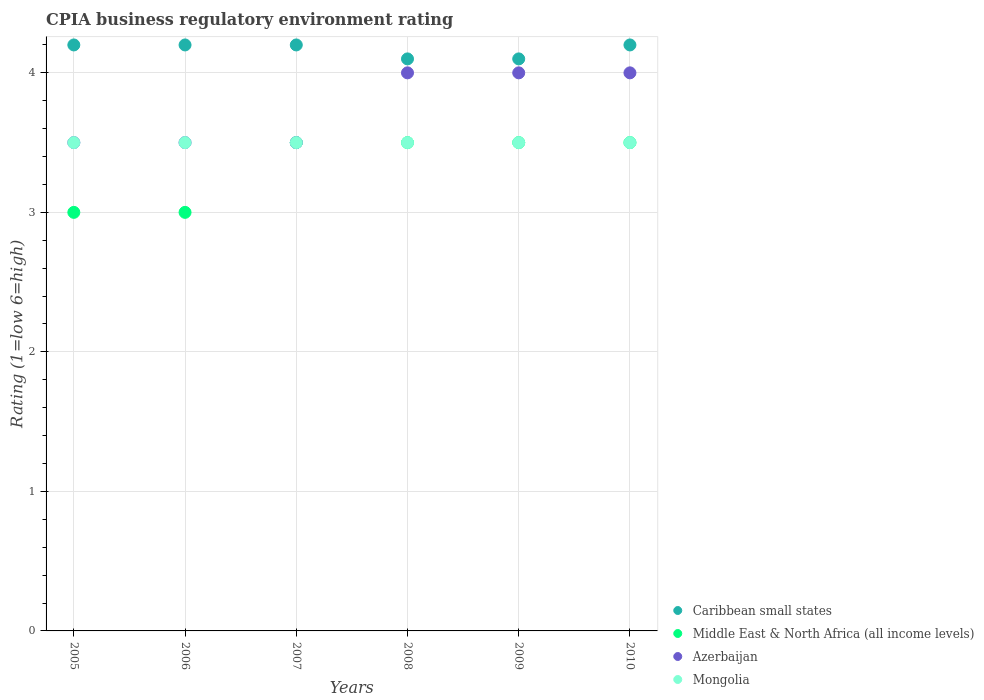Is the number of dotlines equal to the number of legend labels?
Offer a terse response. Yes. Across all years, what is the maximum CPIA rating in Caribbean small states?
Provide a short and direct response. 4.2. Across all years, what is the minimum CPIA rating in Mongolia?
Provide a short and direct response. 3.5. In which year was the CPIA rating in Caribbean small states maximum?
Give a very brief answer. 2005. In which year was the CPIA rating in Azerbaijan minimum?
Provide a succinct answer. 2005. What is the difference between the CPIA rating in Caribbean small states in 2009 and the CPIA rating in Middle East & North Africa (all income levels) in 2010?
Keep it short and to the point. 0.6. What is the average CPIA rating in Middle East & North Africa (all income levels) per year?
Make the answer very short. 3.33. In the year 2010, what is the difference between the CPIA rating in Caribbean small states and CPIA rating in Azerbaijan?
Make the answer very short. 0.2. In how many years, is the CPIA rating in Caribbean small states greater than 3.4?
Offer a very short reply. 6. Is the CPIA rating in Middle East & North Africa (all income levels) in 2005 less than that in 2010?
Your response must be concise. Yes. Is the difference between the CPIA rating in Caribbean small states in 2007 and 2010 greater than the difference between the CPIA rating in Azerbaijan in 2007 and 2010?
Provide a short and direct response. Yes. What is the difference between the highest and the lowest CPIA rating in Caribbean small states?
Offer a terse response. 0.1. In how many years, is the CPIA rating in Caribbean small states greater than the average CPIA rating in Caribbean small states taken over all years?
Provide a succinct answer. 4. Is the sum of the CPIA rating in Caribbean small states in 2005 and 2009 greater than the maximum CPIA rating in Middle East & North Africa (all income levels) across all years?
Offer a very short reply. Yes. Does the CPIA rating in Azerbaijan monotonically increase over the years?
Keep it short and to the point. No. How many years are there in the graph?
Provide a short and direct response. 6. Does the graph contain any zero values?
Provide a succinct answer. No. What is the title of the graph?
Offer a very short reply. CPIA business regulatory environment rating. Does "Botswana" appear as one of the legend labels in the graph?
Ensure brevity in your answer.  No. What is the label or title of the X-axis?
Offer a terse response. Years. What is the Rating (1=low 6=high) of Middle East & North Africa (all income levels) in 2005?
Your response must be concise. 3. What is the Rating (1=low 6=high) in Mongolia in 2005?
Keep it short and to the point. 3.5. What is the Rating (1=low 6=high) of Azerbaijan in 2006?
Keep it short and to the point. 3.5. What is the Rating (1=low 6=high) of Caribbean small states in 2007?
Offer a terse response. 4.2. What is the Rating (1=low 6=high) in Middle East & North Africa (all income levels) in 2007?
Your answer should be compact. 3.5. What is the Rating (1=low 6=high) in Azerbaijan in 2007?
Offer a terse response. 3.5. What is the Rating (1=low 6=high) in Mongolia in 2007?
Give a very brief answer. 3.5. What is the Rating (1=low 6=high) in Caribbean small states in 2008?
Provide a succinct answer. 4.1. What is the Rating (1=low 6=high) of Middle East & North Africa (all income levels) in 2008?
Make the answer very short. 3.5. What is the Rating (1=low 6=high) in Azerbaijan in 2008?
Offer a very short reply. 4. What is the Rating (1=low 6=high) of Mongolia in 2008?
Provide a short and direct response. 3.5. What is the Rating (1=low 6=high) in Caribbean small states in 2009?
Ensure brevity in your answer.  4.1. What is the Rating (1=low 6=high) of Middle East & North Africa (all income levels) in 2009?
Your answer should be compact. 3.5. What is the Rating (1=low 6=high) of Azerbaijan in 2009?
Keep it short and to the point. 4. What is the Rating (1=low 6=high) of Middle East & North Africa (all income levels) in 2010?
Offer a terse response. 3.5. What is the Rating (1=low 6=high) in Azerbaijan in 2010?
Keep it short and to the point. 4. Across all years, what is the maximum Rating (1=low 6=high) in Mongolia?
Make the answer very short. 3.5. Across all years, what is the minimum Rating (1=low 6=high) in Caribbean small states?
Your answer should be very brief. 4.1. Across all years, what is the minimum Rating (1=low 6=high) in Azerbaijan?
Keep it short and to the point. 3.5. Across all years, what is the minimum Rating (1=low 6=high) of Mongolia?
Provide a succinct answer. 3.5. What is the total Rating (1=low 6=high) in Caribbean small states in the graph?
Keep it short and to the point. 25. What is the total Rating (1=low 6=high) of Middle East & North Africa (all income levels) in the graph?
Provide a succinct answer. 20. What is the total Rating (1=low 6=high) of Azerbaijan in the graph?
Make the answer very short. 22.5. What is the total Rating (1=low 6=high) in Mongolia in the graph?
Provide a short and direct response. 21. What is the difference between the Rating (1=low 6=high) of Azerbaijan in 2005 and that in 2006?
Your response must be concise. 0. What is the difference between the Rating (1=low 6=high) of Caribbean small states in 2005 and that in 2007?
Provide a short and direct response. 0. What is the difference between the Rating (1=low 6=high) of Mongolia in 2005 and that in 2007?
Give a very brief answer. 0. What is the difference between the Rating (1=low 6=high) of Middle East & North Africa (all income levels) in 2005 and that in 2008?
Keep it short and to the point. -0.5. What is the difference between the Rating (1=low 6=high) in Azerbaijan in 2005 and that in 2008?
Provide a short and direct response. -0.5. What is the difference between the Rating (1=low 6=high) in Mongolia in 2005 and that in 2008?
Give a very brief answer. 0. What is the difference between the Rating (1=low 6=high) of Caribbean small states in 2005 and that in 2009?
Make the answer very short. 0.1. What is the difference between the Rating (1=low 6=high) in Middle East & North Africa (all income levels) in 2005 and that in 2009?
Your answer should be compact. -0.5. What is the difference between the Rating (1=low 6=high) of Azerbaijan in 2005 and that in 2009?
Make the answer very short. -0.5. What is the difference between the Rating (1=low 6=high) of Mongolia in 2005 and that in 2009?
Offer a very short reply. 0. What is the difference between the Rating (1=low 6=high) of Middle East & North Africa (all income levels) in 2005 and that in 2010?
Your response must be concise. -0.5. What is the difference between the Rating (1=low 6=high) in Mongolia in 2005 and that in 2010?
Provide a short and direct response. 0. What is the difference between the Rating (1=low 6=high) in Azerbaijan in 2006 and that in 2007?
Keep it short and to the point. 0. What is the difference between the Rating (1=low 6=high) in Mongolia in 2006 and that in 2007?
Ensure brevity in your answer.  0. What is the difference between the Rating (1=low 6=high) in Middle East & North Africa (all income levels) in 2006 and that in 2008?
Your response must be concise. -0.5. What is the difference between the Rating (1=low 6=high) of Mongolia in 2006 and that in 2008?
Offer a very short reply. 0. What is the difference between the Rating (1=low 6=high) in Azerbaijan in 2006 and that in 2009?
Offer a terse response. -0.5. What is the difference between the Rating (1=low 6=high) of Caribbean small states in 2006 and that in 2010?
Keep it short and to the point. 0. What is the difference between the Rating (1=low 6=high) in Middle East & North Africa (all income levels) in 2006 and that in 2010?
Give a very brief answer. -0.5. What is the difference between the Rating (1=low 6=high) in Caribbean small states in 2007 and that in 2008?
Your answer should be compact. 0.1. What is the difference between the Rating (1=low 6=high) of Azerbaijan in 2007 and that in 2008?
Offer a very short reply. -0.5. What is the difference between the Rating (1=low 6=high) of Azerbaijan in 2007 and that in 2009?
Ensure brevity in your answer.  -0.5. What is the difference between the Rating (1=low 6=high) of Middle East & North Africa (all income levels) in 2007 and that in 2010?
Your answer should be compact. 0. What is the difference between the Rating (1=low 6=high) of Azerbaijan in 2008 and that in 2009?
Your answer should be compact. 0. What is the difference between the Rating (1=low 6=high) in Caribbean small states in 2008 and that in 2010?
Give a very brief answer. -0.1. What is the difference between the Rating (1=low 6=high) of Middle East & North Africa (all income levels) in 2008 and that in 2010?
Provide a succinct answer. 0. What is the difference between the Rating (1=low 6=high) of Caribbean small states in 2009 and that in 2010?
Keep it short and to the point. -0.1. What is the difference between the Rating (1=low 6=high) in Middle East & North Africa (all income levels) in 2009 and that in 2010?
Provide a short and direct response. 0. What is the difference between the Rating (1=low 6=high) of Mongolia in 2009 and that in 2010?
Provide a short and direct response. 0. What is the difference between the Rating (1=low 6=high) of Caribbean small states in 2005 and the Rating (1=low 6=high) of Azerbaijan in 2006?
Give a very brief answer. 0.7. What is the difference between the Rating (1=low 6=high) of Caribbean small states in 2005 and the Rating (1=low 6=high) of Mongolia in 2006?
Make the answer very short. 0.7. What is the difference between the Rating (1=low 6=high) in Middle East & North Africa (all income levels) in 2005 and the Rating (1=low 6=high) in Mongolia in 2006?
Provide a short and direct response. -0.5. What is the difference between the Rating (1=low 6=high) in Caribbean small states in 2005 and the Rating (1=low 6=high) in Mongolia in 2007?
Ensure brevity in your answer.  0.7. What is the difference between the Rating (1=low 6=high) in Middle East & North Africa (all income levels) in 2005 and the Rating (1=low 6=high) in Azerbaijan in 2007?
Your answer should be very brief. -0.5. What is the difference between the Rating (1=low 6=high) in Middle East & North Africa (all income levels) in 2005 and the Rating (1=low 6=high) in Mongolia in 2007?
Offer a terse response. -0.5. What is the difference between the Rating (1=low 6=high) in Caribbean small states in 2005 and the Rating (1=low 6=high) in Middle East & North Africa (all income levels) in 2008?
Ensure brevity in your answer.  0.7. What is the difference between the Rating (1=low 6=high) of Caribbean small states in 2005 and the Rating (1=low 6=high) of Middle East & North Africa (all income levels) in 2009?
Provide a short and direct response. 0.7. What is the difference between the Rating (1=low 6=high) in Caribbean small states in 2005 and the Rating (1=low 6=high) in Azerbaijan in 2009?
Make the answer very short. 0.2. What is the difference between the Rating (1=low 6=high) of Middle East & North Africa (all income levels) in 2005 and the Rating (1=low 6=high) of Mongolia in 2009?
Ensure brevity in your answer.  -0.5. What is the difference between the Rating (1=low 6=high) in Azerbaijan in 2005 and the Rating (1=low 6=high) in Mongolia in 2009?
Your response must be concise. 0. What is the difference between the Rating (1=low 6=high) in Caribbean small states in 2005 and the Rating (1=low 6=high) in Middle East & North Africa (all income levels) in 2010?
Offer a terse response. 0.7. What is the difference between the Rating (1=low 6=high) in Caribbean small states in 2005 and the Rating (1=low 6=high) in Azerbaijan in 2010?
Provide a short and direct response. 0.2. What is the difference between the Rating (1=low 6=high) of Caribbean small states in 2005 and the Rating (1=low 6=high) of Mongolia in 2010?
Make the answer very short. 0.7. What is the difference between the Rating (1=low 6=high) of Middle East & North Africa (all income levels) in 2005 and the Rating (1=low 6=high) of Azerbaijan in 2010?
Provide a short and direct response. -1. What is the difference between the Rating (1=low 6=high) of Middle East & North Africa (all income levels) in 2005 and the Rating (1=low 6=high) of Mongolia in 2010?
Provide a short and direct response. -0.5. What is the difference between the Rating (1=low 6=high) in Azerbaijan in 2005 and the Rating (1=low 6=high) in Mongolia in 2010?
Provide a succinct answer. 0. What is the difference between the Rating (1=low 6=high) of Middle East & North Africa (all income levels) in 2006 and the Rating (1=low 6=high) of Mongolia in 2007?
Provide a succinct answer. -0.5. What is the difference between the Rating (1=low 6=high) of Caribbean small states in 2006 and the Rating (1=low 6=high) of Middle East & North Africa (all income levels) in 2008?
Give a very brief answer. 0.7. What is the difference between the Rating (1=low 6=high) in Caribbean small states in 2006 and the Rating (1=low 6=high) in Azerbaijan in 2008?
Ensure brevity in your answer.  0.2. What is the difference between the Rating (1=low 6=high) in Caribbean small states in 2006 and the Rating (1=low 6=high) in Mongolia in 2008?
Your response must be concise. 0.7. What is the difference between the Rating (1=low 6=high) of Middle East & North Africa (all income levels) in 2006 and the Rating (1=low 6=high) of Azerbaijan in 2008?
Your answer should be compact. -1. What is the difference between the Rating (1=low 6=high) of Middle East & North Africa (all income levels) in 2006 and the Rating (1=low 6=high) of Mongolia in 2008?
Keep it short and to the point. -0.5. What is the difference between the Rating (1=low 6=high) of Caribbean small states in 2006 and the Rating (1=low 6=high) of Azerbaijan in 2009?
Offer a terse response. 0.2. What is the difference between the Rating (1=low 6=high) in Middle East & North Africa (all income levels) in 2006 and the Rating (1=low 6=high) in Azerbaijan in 2009?
Offer a terse response. -1. What is the difference between the Rating (1=low 6=high) in Azerbaijan in 2006 and the Rating (1=low 6=high) in Mongolia in 2009?
Offer a terse response. 0. What is the difference between the Rating (1=low 6=high) of Caribbean small states in 2006 and the Rating (1=low 6=high) of Middle East & North Africa (all income levels) in 2010?
Keep it short and to the point. 0.7. What is the difference between the Rating (1=low 6=high) in Caribbean small states in 2006 and the Rating (1=low 6=high) in Azerbaijan in 2010?
Provide a succinct answer. 0.2. What is the difference between the Rating (1=low 6=high) in Caribbean small states in 2006 and the Rating (1=low 6=high) in Mongolia in 2010?
Keep it short and to the point. 0.7. What is the difference between the Rating (1=low 6=high) in Caribbean small states in 2007 and the Rating (1=low 6=high) in Middle East & North Africa (all income levels) in 2008?
Your answer should be compact. 0.7. What is the difference between the Rating (1=low 6=high) of Caribbean small states in 2007 and the Rating (1=low 6=high) of Azerbaijan in 2008?
Your response must be concise. 0.2. What is the difference between the Rating (1=low 6=high) of Caribbean small states in 2007 and the Rating (1=low 6=high) of Mongolia in 2008?
Ensure brevity in your answer.  0.7. What is the difference between the Rating (1=low 6=high) of Caribbean small states in 2007 and the Rating (1=low 6=high) of Middle East & North Africa (all income levels) in 2009?
Make the answer very short. 0.7. What is the difference between the Rating (1=low 6=high) of Caribbean small states in 2007 and the Rating (1=low 6=high) of Azerbaijan in 2009?
Provide a succinct answer. 0.2. What is the difference between the Rating (1=low 6=high) in Caribbean small states in 2007 and the Rating (1=low 6=high) in Mongolia in 2009?
Offer a very short reply. 0.7. What is the difference between the Rating (1=low 6=high) of Middle East & North Africa (all income levels) in 2007 and the Rating (1=low 6=high) of Mongolia in 2009?
Offer a very short reply. 0. What is the difference between the Rating (1=low 6=high) in Caribbean small states in 2007 and the Rating (1=low 6=high) in Mongolia in 2010?
Your response must be concise. 0.7. What is the difference between the Rating (1=low 6=high) in Middle East & North Africa (all income levels) in 2007 and the Rating (1=low 6=high) in Azerbaijan in 2010?
Offer a very short reply. -0.5. What is the difference between the Rating (1=low 6=high) of Azerbaijan in 2007 and the Rating (1=low 6=high) of Mongolia in 2010?
Offer a terse response. 0. What is the difference between the Rating (1=low 6=high) of Caribbean small states in 2008 and the Rating (1=low 6=high) of Azerbaijan in 2009?
Make the answer very short. 0.1. What is the difference between the Rating (1=low 6=high) in Azerbaijan in 2008 and the Rating (1=low 6=high) in Mongolia in 2009?
Give a very brief answer. 0.5. What is the difference between the Rating (1=low 6=high) of Caribbean small states in 2008 and the Rating (1=low 6=high) of Middle East & North Africa (all income levels) in 2010?
Ensure brevity in your answer.  0.6. What is the difference between the Rating (1=low 6=high) in Caribbean small states in 2008 and the Rating (1=low 6=high) in Azerbaijan in 2010?
Ensure brevity in your answer.  0.1. What is the difference between the Rating (1=low 6=high) in Caribbean small states in 2008 and the Rating (1=low 6=high) in Mongolia in 2010?
Ensure brevity in your answer.  0.6. What is the difference between the Rating (1=low 6=high) in Middle East & North Africa (all income levels) in 2008 and the Rating (1=low 6=high) in Mongolia in 2010?
Your answer should be compact. 0. What is the difference between the Rating (1=low 6=high) of Azerbaijan in 2008 and the Rating (1=low 6=high) of Mongolia in 2010?
Ensure brevity in your answer.  0.5. What is the difference between the Rating (1=low 6=high) in Caribbean small states in 2009 and the Rating (1=low 6=high) in Mongolia in 2010?
Provide a succinct answer. 0.6. What is the difference between the Rating (1=low 6=high) in Middle East & North Africa (all income levels) in 2009 and the Rating (1=low 6=high) in Azerbaijan in 2010?
Ensure brevity in your answer.  -0.5. What is the difference between the Rating (1=low 6=high) in Azerbaijan in 2009 and the Rating (1=low 6=high) in Mongolia in 2010?
Your answer should be compact. 0.5. What is the average Rating (1=low 6=high) in Caribbean small states per year?
Give a very brief answer. 4.17. What is the average Rating (1=low 6=high) in Azerbaijan per year?
Provide a succinct answer. 3.75. What is the average Rating (1=low 6=high) of Mongolia per year?
Make the answer very short. 3.5. In the year 2005, what is the difference between the Rating (1=low 6=high) of Caribbean small states and Rating (1=low 6=high) of Azerbaijan?
Make the answer very short. 0.7. In the year 2005, what is the difference between the Rating (1=low 6=high) of Caribbean small states and Rating (1=low 6=high) of Mongolia?
Ensure brevity in your answer.  0.7. In the year 2005, what is the difference between the Rating (1=low 6=high) in Middle East & North Africa (all income levels) and Rating (1=low 6=high) in Azerbaijan?
Give a very brief answer. -0.5. In the year 2006, what is the difference between the Rating (1=low 6=high) in Caribbean small states and Rating (1=low 6=high) in Middle East & North Africa (all income levels)?
Your answer should be very brief. 1.2. In the year 2006, what is the difference between the Rating (1=low 6=high) of Caribbean small states and Rating (1=low 6=high) of Azerbaijan?
Give a very brief answer. 0.7. In the year 2006, what is the difference between the Rating (1=low 6=high) in Middle East & North Africa (all income levels) and Rating (1=low 6=high) in Azerbaijan?
Give a very brief answer. -0.5. In the year 2006, what is the difference between the Rating (1=low 6=high) of Middle East & North Africa (all income levels) and Rating (1=low 6=high) of Mongolia?
Ensure brevity in your answer.  -0.5. In the year 2006, what is the difference between the Rating (1=low 6=high) in Azerbaijan and Rating (1=low 6=high) in Mongolia?
Make the answer very short. 0. In the year 2007, what is the difference between the Rating (1=low 6=high) in Caribbean small states and Rating (1=low 6=high) in Middle East & North Africa (all income levels)?
Ensure brevity in your answer.  0.7. In the year 2008, what is the difference between the Rating (1=low 6=high) in Caribbean small states and Rating (1=low 6=high) in Azerbaijan?
Your answer should be compact. 0.1. In the year 2008, what is the difference between the Rating (1=low 6=high) of Middle East & North Africa (all income levels) and Rating (1=low 6=high) of Azerbaijan?
Your answer should be compact. -0.5. In the year 2008, what is the difference between the Rating (1=low 6=high) in Middle East & North Africa (all income levels) and Rating (1=low 6=high) in Mongolia?
Keep it short and to the point. 0. In the year 2009, what is the difference between the Rating (1=low 6=high) of Caribbean small states and Rating (1=low 6=high) of Mongolia?
Provide a short and direct response. 0.6. In the year 2009, what is the difference between the Rating (1=low 6=high) of Middle East & North Africa (all income levels) and Rating (1=low 6=high) of Azerbaijan?
Your response must be concise. -0.5. In the year 2009, what is the difference between the Rating (1=low 6=high) in Middle East & North Africa (all income levels) and Rating (1=low 6=high) in Mongolia?
Make the answer very short. 0. In the year 2009, what is the difference between the Rating (1=low 6=high) of Azerbaijan and Rating (1=low 6=high) of Mongolia?
Ensure brevity in your answer.  0.5. In the year 2010, what is the difference between the Rating (1=low 6=high) of Caribbean small states and Rating (1=low 6=high) of Azerbaijan?
Your response must be concise. 0.2. In the year 2010, what is the difference between the Rating (1=low 6=high) in Caribbean small states and Rating (1=low 6=high) in Mongolia?
Ensure brevity in your answer.  0.7. In the year 2010, what is the difference between the Rating (1=low 6=high) in Middle East & North Africa (all income levels) and Rating (1=low 6=high) in Azerbaijan?
Ensure brevity in your answer.  -0.5. In the year 2010, what is the difference between the Rating (1=low 6=high) of Azerbaijan and Rating (1=low 6=high) of Mongolia?
Your answer should be very brief. 0.5. What is the ratio of the Rating (1=low 6=high) in Caribbean small states in 2005 to that in 2006?
Offer a very short reply. 1. What is the ratio of the Rating (1=low 6=high) of Azerbaijan in 2005 to that in 2006?
Provide a short and direct response. 1. What is the ratio of the Rating (1=low 6=high) in Azerbaijan in 2005 to that in 2007?
Make the answer very short. 1. What is the ratio of the Rating (1=low 6=high) of Caribbean small states in 2005 to that in 2008?
Ensure brevity in your answer.  1.02. What is the ratio of the Rating (1=low 6=high) of Mongolia in 2005 to that in 2008?
Make the answer very short. 1. What is the ratio of the Rating (1=low 6=high) in Caribbean small states in 2005 to that in 2009?
Your answer should be very brief. 1.02. What is the ratio of the Rating (1=low 6=high) of Middle East & North Africa (all income levels) in 2005 to that in 2009?
Offer a terse response. 0.86. What is the ratio of the Rating (1=low 6=high) of Azerbaijan in 2005 to that in 2009?
Offer a terse response. 0.88. What is the ratio of the Rating (1=low 6=high) in Caribbean small states in 2005 to that in 2010?
Keep it short and to the point. 1. What is the ratio of the Rating (1=low 6=high) in Mongolia in 2005 to that in 2010?
Keep it short and to the point. 1. What is the ratio of the Rating (1=low 6=high) of Azerbaijan in 2006 to that in 2007?
Offer a terse response. 1. What is the ratio of the Rating (1=low 6=high) in Mongolia in 2006 to that in 2007?
Provide a succinct answer. 1. What is the ratio of the Rating (1=low 6=high) of Caribbean small states in 2006 to that in 2008?
Ensure brevity in your answer.  1.02. What is the ratio of the Rating (1=low 6=high) of Caribbean small states in 2006 to that in 2009?
Keep it short and to the point. 1.02. What is the ratio of the Rating (1=low 6=high) in Azerbaijan in 2006 to that in 2009?
Your answer should be very brief. 0.88. What is the ratio of the Rating (1=low 6=high) of Middle East & North Africa (all income levels) in 2006 to that in 2010?
Give a very brief answer. 0.86. What is the ratio of the Rating (1=low 6=high) of Caribbean small states in 2007 to that in 2008?
Provide a succinct answer. 1.02. What is the ratio of the Rating (1=low 6=high) of Middle East & North Africa (all income levels) in 2007 to that in 2008?
Your response must be concise. 1. What is the ratio of the Rating (1=low 6=high) in Azerbaijan in 2007 to that in 2008?
Your answer should be compact. 0.88. What is the ratio of the Rating (1=low 6=high) in Caribbean small states in 2007 to that in 2009?
Offer a terse response. 1.02. What is the ratio of the Rating (1=low 6=high) in Middle East & North Africa (all income levels) in 2007 to that in 2009?
Keep it short and to the point. 1. What is the ratio of the Rating (1=low 6=high) in Azerbaijan in 2007 to that in 2009?
Your response must be concise. 0.88. What is the ratio of the Rating (1=low 6=high) in Mongolia in 2007 to that in 2009?
Keep it short and to the point. 1. What is the ratio of the Rating (1=low 6=high) in Caribbean small states in 2007 to that in 2010?
Give a very brief answer. 1. What is the ratio of the Rating (1=low 6=high) in Azerbaijan in 2007 to that in 2010?
Your response must be concise. 0.88. What is the ratio of the Rating (1=low 6=high) of Mongolia in 2007 to that in 2010?
Provide a short and direct response. 1. What is the ratio of the Rating (1=low 6=high) in Caribbean small states in 2008 to that in 2009?
Your answer should be very brief. 1. What is the ratio of the Rating (1=low 6=high) of Middle East & North Africa (all income levels) in 2008 to that in 2009?
Give a very brief answer. 1. What is the ratio of the Rating (1=low 6=high) in Mongolia in 2008 to that in 2009?
Keep it short and to the point. 1. What is the ratio of the Rating (1=low 6=high) of Caribbean small states in 2008 to that in 2010?
Offer a terse response. 0.98. What is the ratio of the Rating (1=low 6=high) of Mongolia in 2008 to that in 2010?
Your response must be concise. 1. What is the ratio of the Rating (1=low 6=high) in Caribbean small states in 2009 to that in 2010?
Offer a very short reply. 0.98. What is the ratio of the Rating (1=low 6=high) of Middle East & North Africa (all income levels) in 2009 to that in 2010?
Keep it short and to the point. 1. What is the ratio of the Rating (1=low 6=high) of Azerbaijan in 2009 to that in 2010?
Offer a very short reply. 1. What is the difference between the highest and the second highest Rating (1=low 6=high) of Azerbaijan?
Offer a very short reply. 0. What is the difference between the highest and the lowest Rating (1=low 6=high) of Caribbean small states?
Your answer should be compact. 0.1. What is the difference between the highest and the lowest Rating (1=low 6=high) of Mongolia?
Keep it short and to the point. 0. 